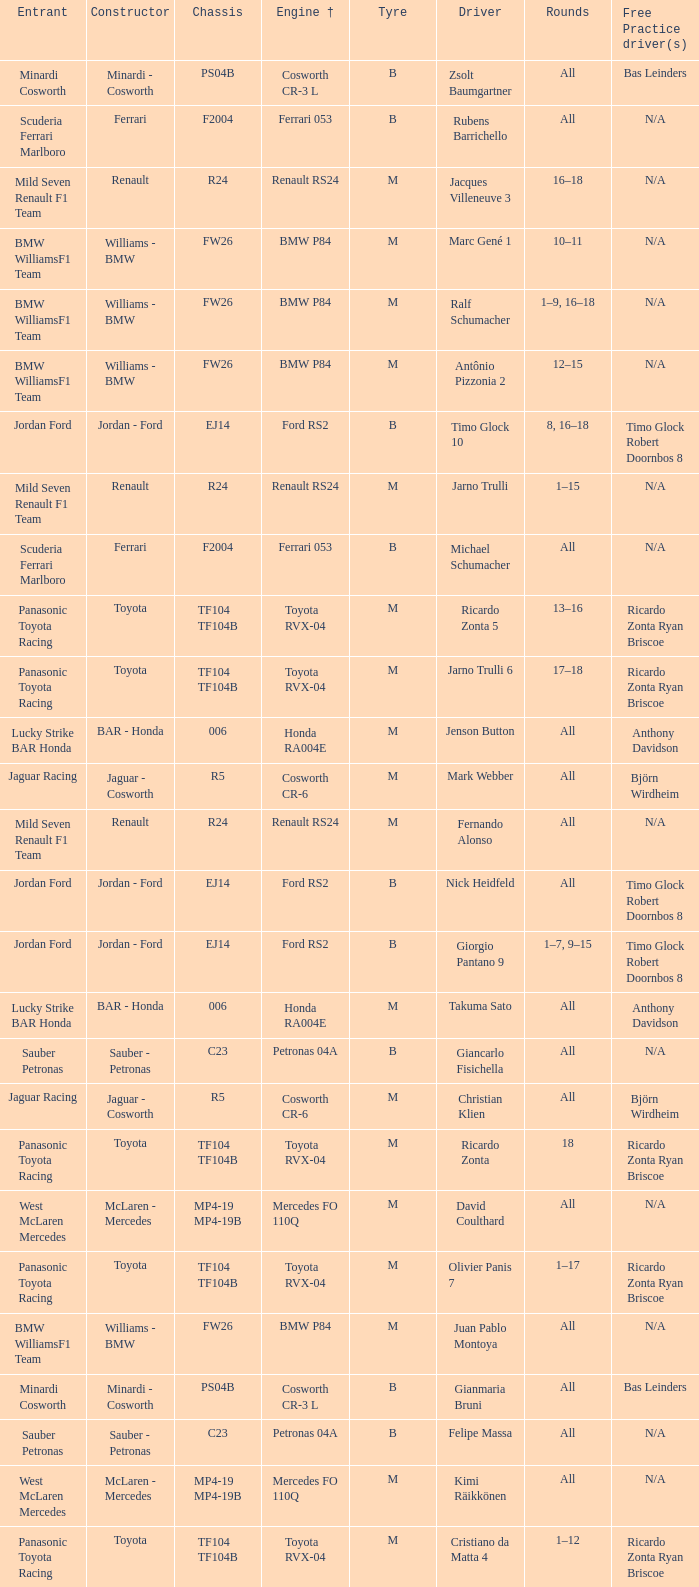What kind of chassis does Ricardo Zonta have? TF104 TF104B. 